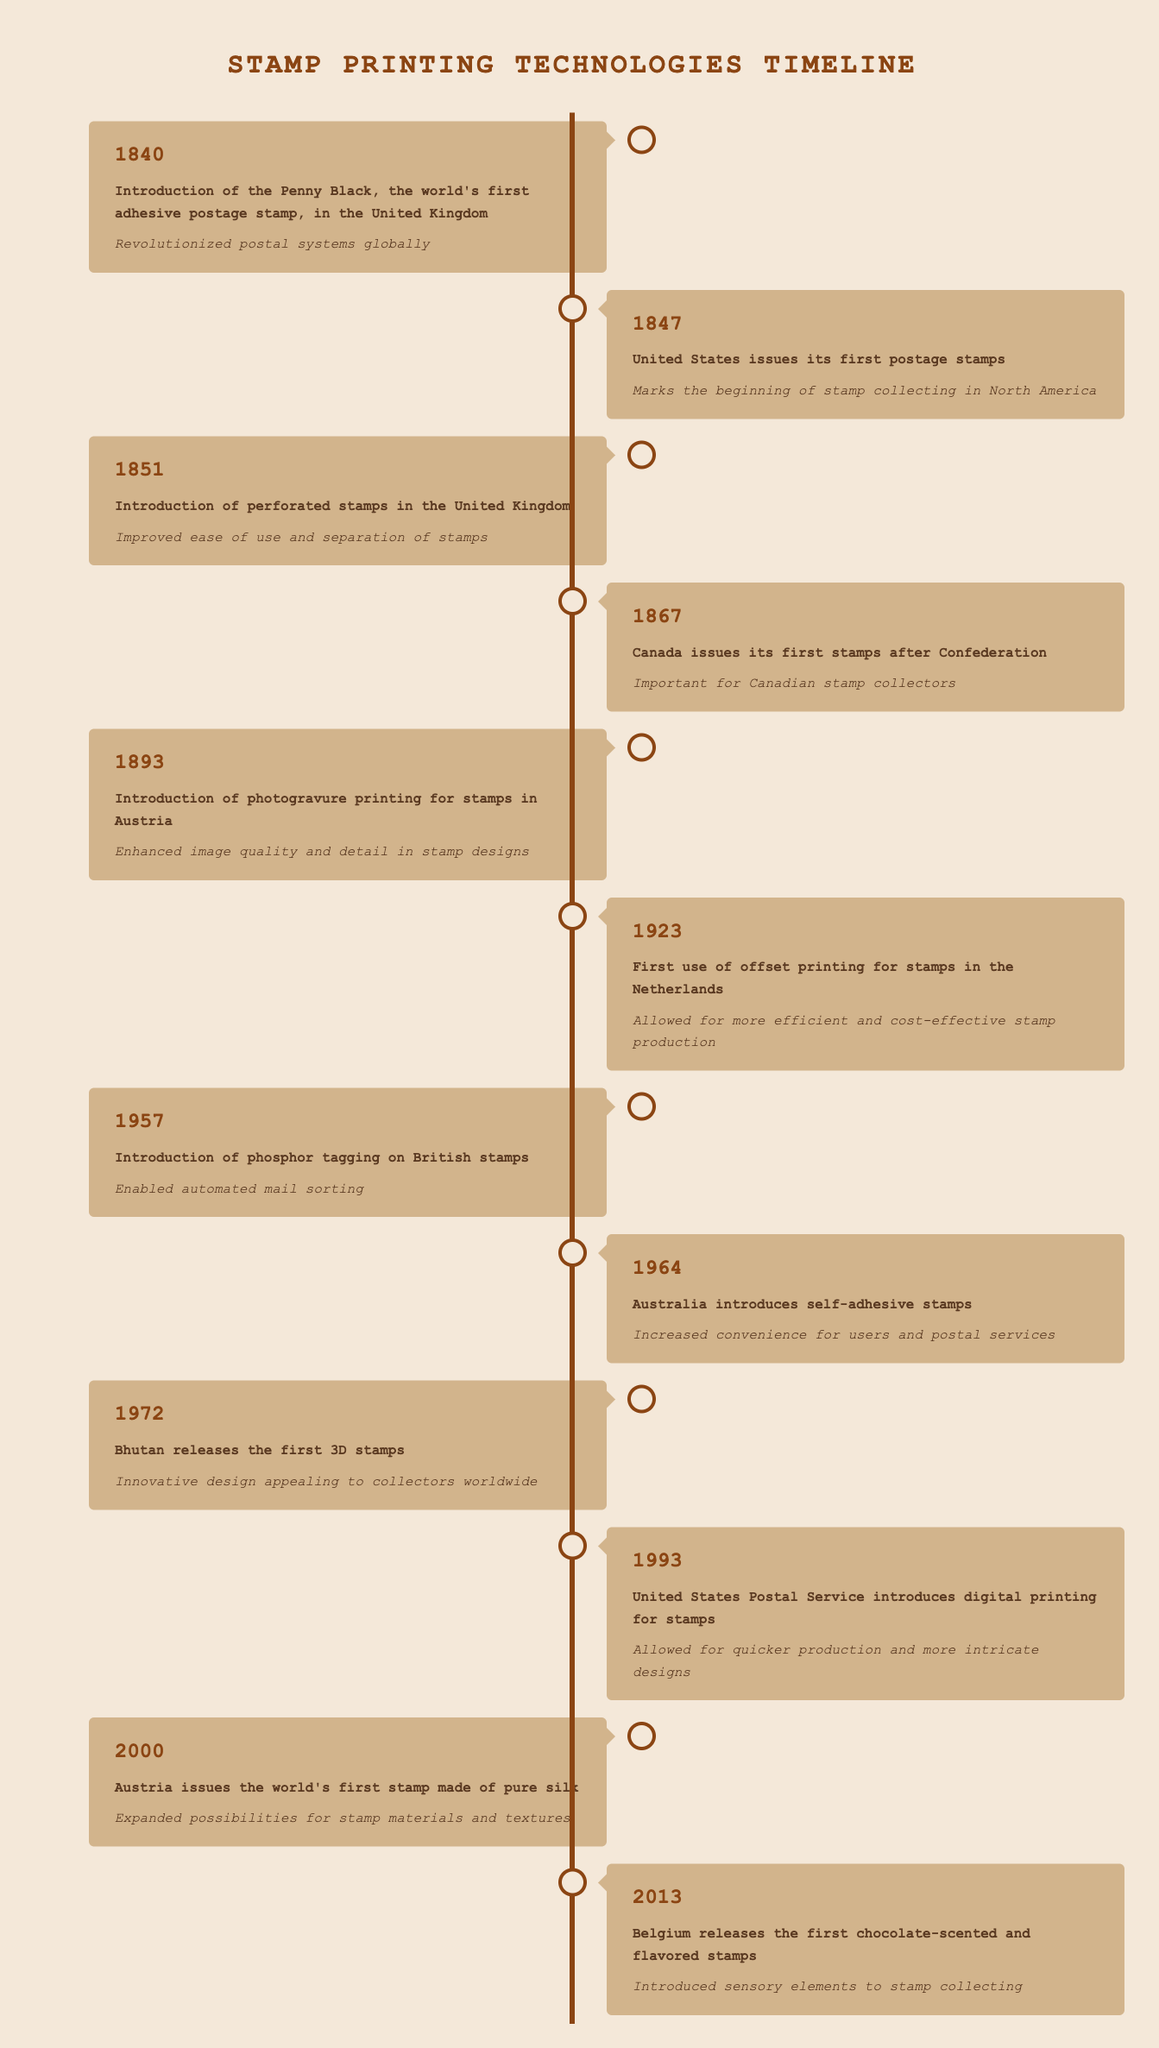What year did the United States issue its first postage stamps? The table states that the United States issued its first postage stamps in 1847. This information is retrieved directly from the corresponding row in the timeline.
Answer: 1847 Which event marked the introduction of perforated stamps? According to the table, the introduction of perforated stamps occurred in 1851 in the United Kingdom. This event can be found in the specified year and event column of the table.
Answer: Introduction of perforated stamps in the United Kingdom Which two innovations in stamp technology were introduced in the 20th century? The table indicates that offset printing was first used in 1923 in the Netherlands and that digital printing was introduced in 1993 by the United States Postal Service. This information is based on filtering the timeline for events occurring in the 20th century.
Answer: Offset printing in 1923 and digital printing in 1993 What is the significance of the Penny Black stamp? The significance of the Penny Black, introduced in 1840, is that it revolutionized postal systems globally, as noted in the timeline. This is a direct retrieval of data from the significance column associated with that event.
Answer: Revolutionized postal systems globally In which event did Bhutan release the first 3D stamps? The timeline shows that Bhutan released the first 3D stamps in 1972. This can be directly referenced from the year and event columns without any complex reasoning.
Answer: 1972 Did Belgium release any innovative stamps after 2000? Yes, the table shows that Belgium released chocolate-scented and flavored stamps in 2013. This verifies the question by checking the event for a notable innovation post-2000.
Answer: Yes Calculate the difference between the first and last years mentioned in the timeline. The first year mentioned is 1840 and the last is 2013. To find the difference, subtract the earlier year from the later year: 2013 - 1840 = 173. This arithmetic operation leads to the final answer.
Answer: 173 How many events listed in the table are significant for collectors in Canada? According to the table, there is one specific event for Canadian collectors: the issuance of its first stamps in 1867. This is singled out by scanning the significance column for any mention of collectors in Canada.
Answer: 1 What technology was introduced to enhance automated mail sorting in 1957? The timeline indicates that phosphor tagging on British stamps was introduced in 1957, allowing for automated mail sorting. This can be easily found within the specified year and event columns.
Answer: Phosphor tagging on British stamps 